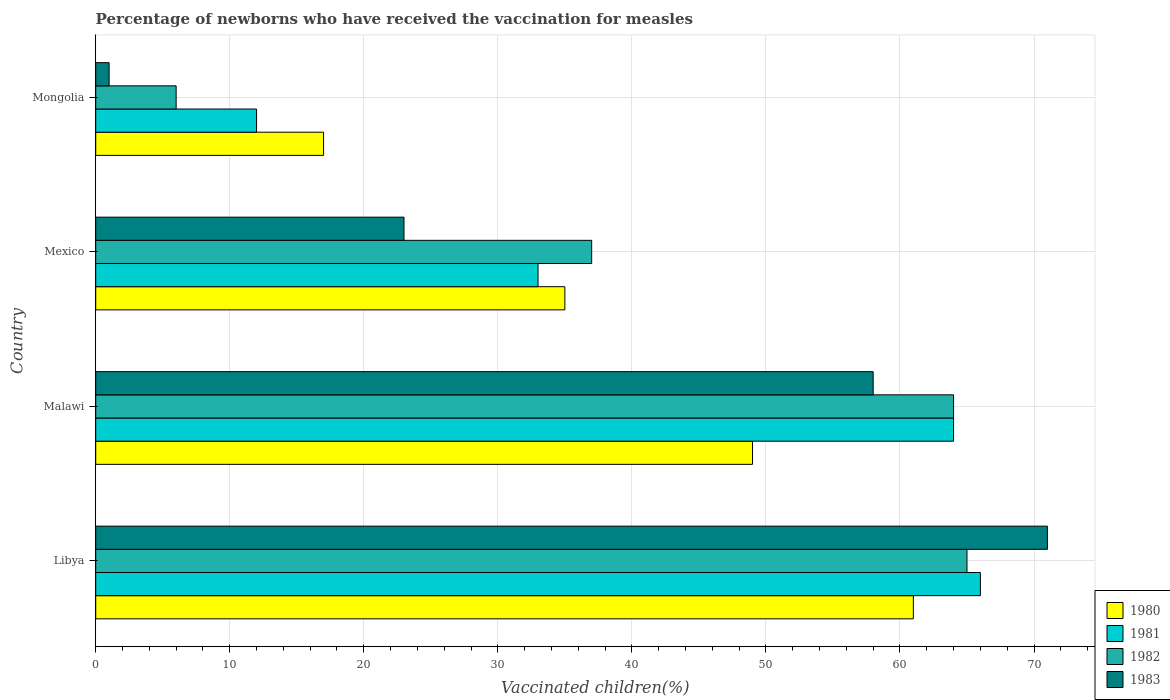How many different coloured bars are there?
Give a very brief answer. 4. How many groups of bars are there?
Your answer should be compact. 4. How many bars are there on the 3rd tick from the top?
Provide a succinct answer. 4. How many bars are there on the 4th tick from the bottom?
Offer a very short reply. 4. What is the label of the 1st group of bars from the top?
Give a very brief answer. Mongolia. In how many cases, is the number of bars for a given country not equal to the number of legend labels?
Your response must be concise. 0. Across all countries, what is the minimum percentage of vaccinated children in 1980?
Offer a terse response. 17. In which country was the percentage of vaccinated children in 1981 maximum?
Your answer should be compact. Libya. In which country was the percentage of vaccinated children in 1983 minimum?
Offer a very short reply. Mongolia. What is the total percentage of vaccinated children in 1980 in the graph?
Offer a terse response. 162. What is the difference between the percentage of vaccinated children in 1980 in Mongolia and the percentage of vaccinated children in 1983 in Libya?
Make the answer very short. -54. What is the average percentage of vaccinated children in 1981 per country?
Your answer should be compact. 43.75. What is the difference between the percentage of vaccinated children in 1980 and percentage of vaccinated children in 1982 in Mongolia?
Give a very brief answer. 11. What is the ratio of the percentage of vaccinated children in 1981 in Malawi to that in Mexico?
Offer a very short reply. 1.94. Is the percentage of vaccinated children in 1983 in Malawi less than that in Mexico?
Make the answer very short. No. Is the difference between the percentage of vaccinated children in 1980 in Malawi and Mexico greater than the difference between the percentage of vaccinated children in 1982 in Malawi and Mexico?
Provide a succinct answer. No. What is the difference between the highest and the lowest percentage of vaccinated children in 1982?
Your answer should be compact. 59. Is it the case that in every country, the sum of the percentage of vaccinated children in 1982 and percentage of vaccinated children in 1983 is greater than the percentage of vaccinated children in 1981?
Keep it short and to the point. No. How many bars are there?
Keep it short and to the point. 16. Does the graph contain grids?
Ensure brevity in your answer.  Yes. How are the legend labels stacked?
Your answer should be very brief. Vertical. What is the title of the graph?
Offer a terse response. Percentage of newborns who have received the vaccination for measles. What is the label or title of the X-axis?
Provide a short and direct response. Vaccinated children(%). What is the label or title of the Y-axis?
Provide a short and direct response. Country. What is the Vaccinated children(%) of 1980 in Libya?
Provide a short and direct response. 61. What is the Vaccinated children(%) in 1981 in Libya?
Provide a succinct answer. 66. What is the Vaccinated children(%) of 1983 in Libya?
Your answer should be very brief. 71. What is the Vaccinated children(%) of 1980 in Malawi?
Ensure brevity in your answer.  49. What is the Vaccinated children(%) in 1981 in Malawi?
Your answer should be very brief. 64. What is the Vaccinated children(%) of 1982 in Malawi?
Keep it short and to the point. 64. What is the Vaccinated children(%) in 1980 in Mexico?
Your response must be concise. 35. What is the Vaccinated children(%) of 1981 in Mexico?
Provide a succinct answer. 33. What is the Vaccinated children(%) in 1983 in Mexico?
Make the answer very short. 23. What is the Vaccinated children(%) in 1982 in Mongolia?
Your answer should be compact. 6. Across all countries, what is the maximum Vaccinated children(%) of 1981?
Ensure brevity in your answer.  66. Across all countries, what is the maximum Vaccinated children(%) of 1982?
Provide a short and direct response. 65. Across all countries, what is the minimum Vaccinated children(%) of 1980?
Your answer should be very brief. 17. Across all countries, what is the minimum Vaccinated children(%) in 1981?
Make the answer very short. 12. What is the total Vaccinated children(%) of 1980 in the graph?
Provide a succinct answer. 162. What is the total Vaccinated children(%) in 1981 in the graph?
Provide a succinct answer. 175. What is the total Vaccinated children(%) of 1982 in the graph?
Give a very brief answer. 172. What is the total Vaccinated children(%) in 1983 in the graph?
Give a very brief answer. 153. What is the difference between the Vaccinated children(%) of 1980 in Libya and that in Malawi?
Ensure brevity in your answer.  12. What is the difference between the Vaccinated children(%) in 1983 in Libya and that in Malawi?
Your answer should be compact. 13. What is the difference between the Vaccinated children(%) in 1980 in Libya and that in Mexico?
Keep it short and to the point. 26. What is the difference between the Vaccinated children(%) of 1981 in Libya and that in Mexico?
Make the answer very short. 33. What is the difference between the Vaccinated children(%) of 1982 in Libya and that in Mexico?
Keep it short and to the point. 28. What is the difference between the Vaccinated children(%) of 1980 in Libya and that in Mongolia?
Keep it short and to the point. 44. What is the difference between the Vaccinated children(%) of 1983 in Malawi and that in Mexico?
Your answer should be compact. 35. What is the difference between the Vaccinated children(%) in 1982 in Malawi and that in Mongolia?
Your answer should be very brief. 58. What is the difference between the Vaccinated children(%) of 1981 in Mexico and that in Mongolia?
Offer a very short reply. 21. What is the difference between the Vaccinated children(%) of 1982 in Mexico and that in Mongolia?
Offer a terse response. 31. What is the difference between the Vaccinated children(%) of 1983 in Mexico and that in Mongolia?
Your response must be concise. 22. What is the difference between the Vaccinated children(%) in 1980 in Libya and the Vaccinated children(%) in 1981 in Malawi?
Your response must be concise. -3. What is the difference between the Vaccinated children(%) of 1980 in Libya and the Vaccinated children(%) of 1982 in Mexico?
Keep it short and to the point. 24. What is the difference between the Vaccinated children(%) of 1980 in Libya and the Vaccinated children(%) of 1983 in Mexico?
Provide a succinct answer. 38. What is the difference between the Vaccinated children(%) in 1981 in Libya and the Vaccinated children(%) in 1982 in Mexico?
Your response must be concise. 29. What is the difference between the Vaccinated children(%) of 1981 in Libya and the Vaccinated children(%) of 1983 in Mexico?
Your response must be concise. 43. What is the difference between the Vaccinated children(%) in 1980 in Libya and the Vaccinated children(%) in 1981 in Mongolia?
Provide a short and direct response. 49. What is the difference between the Vaccinated children(%) in 1980 in Libya and the Vaccinated children(%) in 1982 in Mongolia?
Your response must be concise. 55. What is the difference between the Vaccinated children(%) of 1981 in Libya and the Vaccinated children(%) of 1983 in Mongolia?
Your answer should be compact. 65. What is the difference between the Vaccinated children(%) in 1982 in Libya and the Vaccinated children(%) in 1983 in Mongolia?
Provide a succinct answer. 64. What is the difference between the Vaccinated children(%) of 1980 in Malawi and the Vaccinated children(%) of 1982 in Mexico?
Give a very brief answer. 12. What is the difference between the Vaccinated children(%) of 1980 in Malawi and the Vaccinated children(%) of 1983 in Mexico?
Your response must be concise. 26. What is the difference between the Vaccinated children(%) in 1981 in Malawi and the Vaccinated children(%) in 1983 in Mexico?
Offer a very short reply. 41. What is the difference between the Vaccinated children(%) in 1980 in Malawi and the Vaccinated children(%) in 1983 in Mongolia?
Your answer should be compact. 48. What is the difference between the Vaccinated children(%) in 1981 in Malawi and the Vaccinated children(%) in 1982 in Mongolia?
Your answer should be compact. 58. What is the difference between the Vaccinated children(%) in 1980 in Mexico and the Vaccinated children(%) in 1982 in Mongolia?
Give a very brief answer. 29. What is the difference between the Vaccinated children(%) of 1980 in Mexico and the Vaccinated children(%) of 1983 in Mongolia?
Your response must be concise. 34. What is the difference between the Vaccinated children(%) in 1981 in Mexico and the Vaccinated children(%) in 1982 in Mongolia?
Provide a short and direct response. 27. What is the difference between the Vaccinated children(%) in 1981 in Mexico and the Vaccinated children(%) in 1983 in Mongolia?
Offer a terse response. 32. What is the difference between the Vaccinated children(%) in 1982 in Mexico and the Vaccinated children(%) in 1983 in Mongolia?
Offer a very short reply. 36. What is the average Vaccinated children(%) of 1980 per country?
Your response must be concise. 40.5. What is the average Vaccinated children(%) in 1981 per country?
Your answer should be compact. 43.75. What is the average Vaccinated children(%) in 1983 per country?
Offer a very short reply. 38.25. What is the difference between the Vaccinated children(%) of 1980 and Vaccinated children(%) of 1981 in Libya?
Make the answer very short. -5. What is the difference between the Vaccinated children(%) in 1981 and Vaccinated children(%) in 1982 in Libya?
Your answer should be compact. 1. What is the difference between the Vaccinated children(%) of 1982 and Vaccinated children(%) of 1983 in Malawi?
Offer a very short reply. 6. What is the difference between the Vaccinated children(%) in 1981 and Vaccinated children(%) in 1982 in Mexico?
Offer a very short reply. -4. What is the difference between the Vaccinated children(%) in 1982 and Vaccinated children(%) in 1983 in Mexico?
Offer a very short reply. 14. What is the difference between the Vaccinated children(%) in 1980 and Vaccinated children(%) in 1981 in Mongolia?
Ensure brevity in your answer.  5. What is the difference between the Vaccinated children(%) in 1980 and Vaccinated children(%) in 1983 in Mongolia?
Offer a very short reply. 16. What is the ratio of the Vaccinated children(%) of 1980 in Libya to that in Malawi?
Ensure brevity in your answer.  1.24. What is the ratio of the Vaccinated children(%) in 1981 in Libya to that in Malawi?
Make the answer very short. 1.03. What is the ratio of the Vaccinated children(%) of 1982 in Libya to that in Malawi?
Give a very brief answer. 1.02. What is the ratio of the Vaccinated children(%) of 1983 in Libya to that in Malawi?
Provide a succinct answer. 1.22. What is the ratio of the Vaccinated children(%) of 1980 in Libya to that in Mexico?
Offer a terse response. 1.74. What is the ratio of the Vaccinated children(%) in 1981 in Libya to that in Mexico?
Provide a succinct answer. 2. What is the ratio of the Vaccinated children(%) of 1982 in Libya to that in Mexico?
Provide a short and direct response. 1.76. What is the ratio of the Vaccinated children(%) in 1983 in Libya to that in Mexico?
Offer a terse response. 3.09. What is the ratio of the Vaccinated children(%) of 1980 in Libya to that in Mongolia?
Ensure brevity in your answer.  3.59. What is the ratio of the Vaccinated children(%) of 1982 in Libya to that in Mongolia?
Your answer should be very brief. 10.83. What is the ratio of the Vaccinated children(%) of 1983 in Libya to that in Mongolia?
Make the answer very short. 71. What is the ratio of the Vaccinated children(%) in 1981 in Malawi to that in Mexico?
Make the answer very short. 1.94. What is the ratio of the Vaccinated children(%) of 1982 in Malawi to that in Mexico?
Provide a succinct answer. 1.73. What is the ratio of the Vaccinated children(%) of 1983 in Malawi to that in Mexico?
Provide a short and direct response. 2.52. What is the ratio of the Vaccinated children(%) in 1980 in Malawi to that in Mongolia?
Make the answer very short. 2.88. What is the ratio of the Vaccinated children(%) of 1981 in Malawi to that in Mongolia?
Offer a terse response. 5.33. What is the ratio of the Vaccinated children(%) of 1982 in Malawi to that in Mongolia?
Provide a short and direct response. 10.67. What is the ratio of the Vaccinated children(%) of 1980 in Mexico to that in Mongolia?
Your response must be concise. 2.06. What is the ratio of the Vaccinated children(%) in 1981 in Mexico to that in Mongolia?
Your response must be concise. 2.75. What is the ratio of the Vaccinated children(%) in 1982 in Mexico to that in Mongolia?
Offer a very short reply. 6.17. What is the difference between the highest and the second highest Vaccinated children(%) of 1980?
Offer a terse response. 12. What is the difference between the highest and the second highest Vaccinated children(%) of 1981?
Make the answer very short. 2. What is the difference between the highest and the lowest Vaccinated children(%) of 1980?
Offer a very short reply. 44. What is the difference between the highest and the lowest Vaccinated children(%) in 1981?
Your response must be concise. 54. 